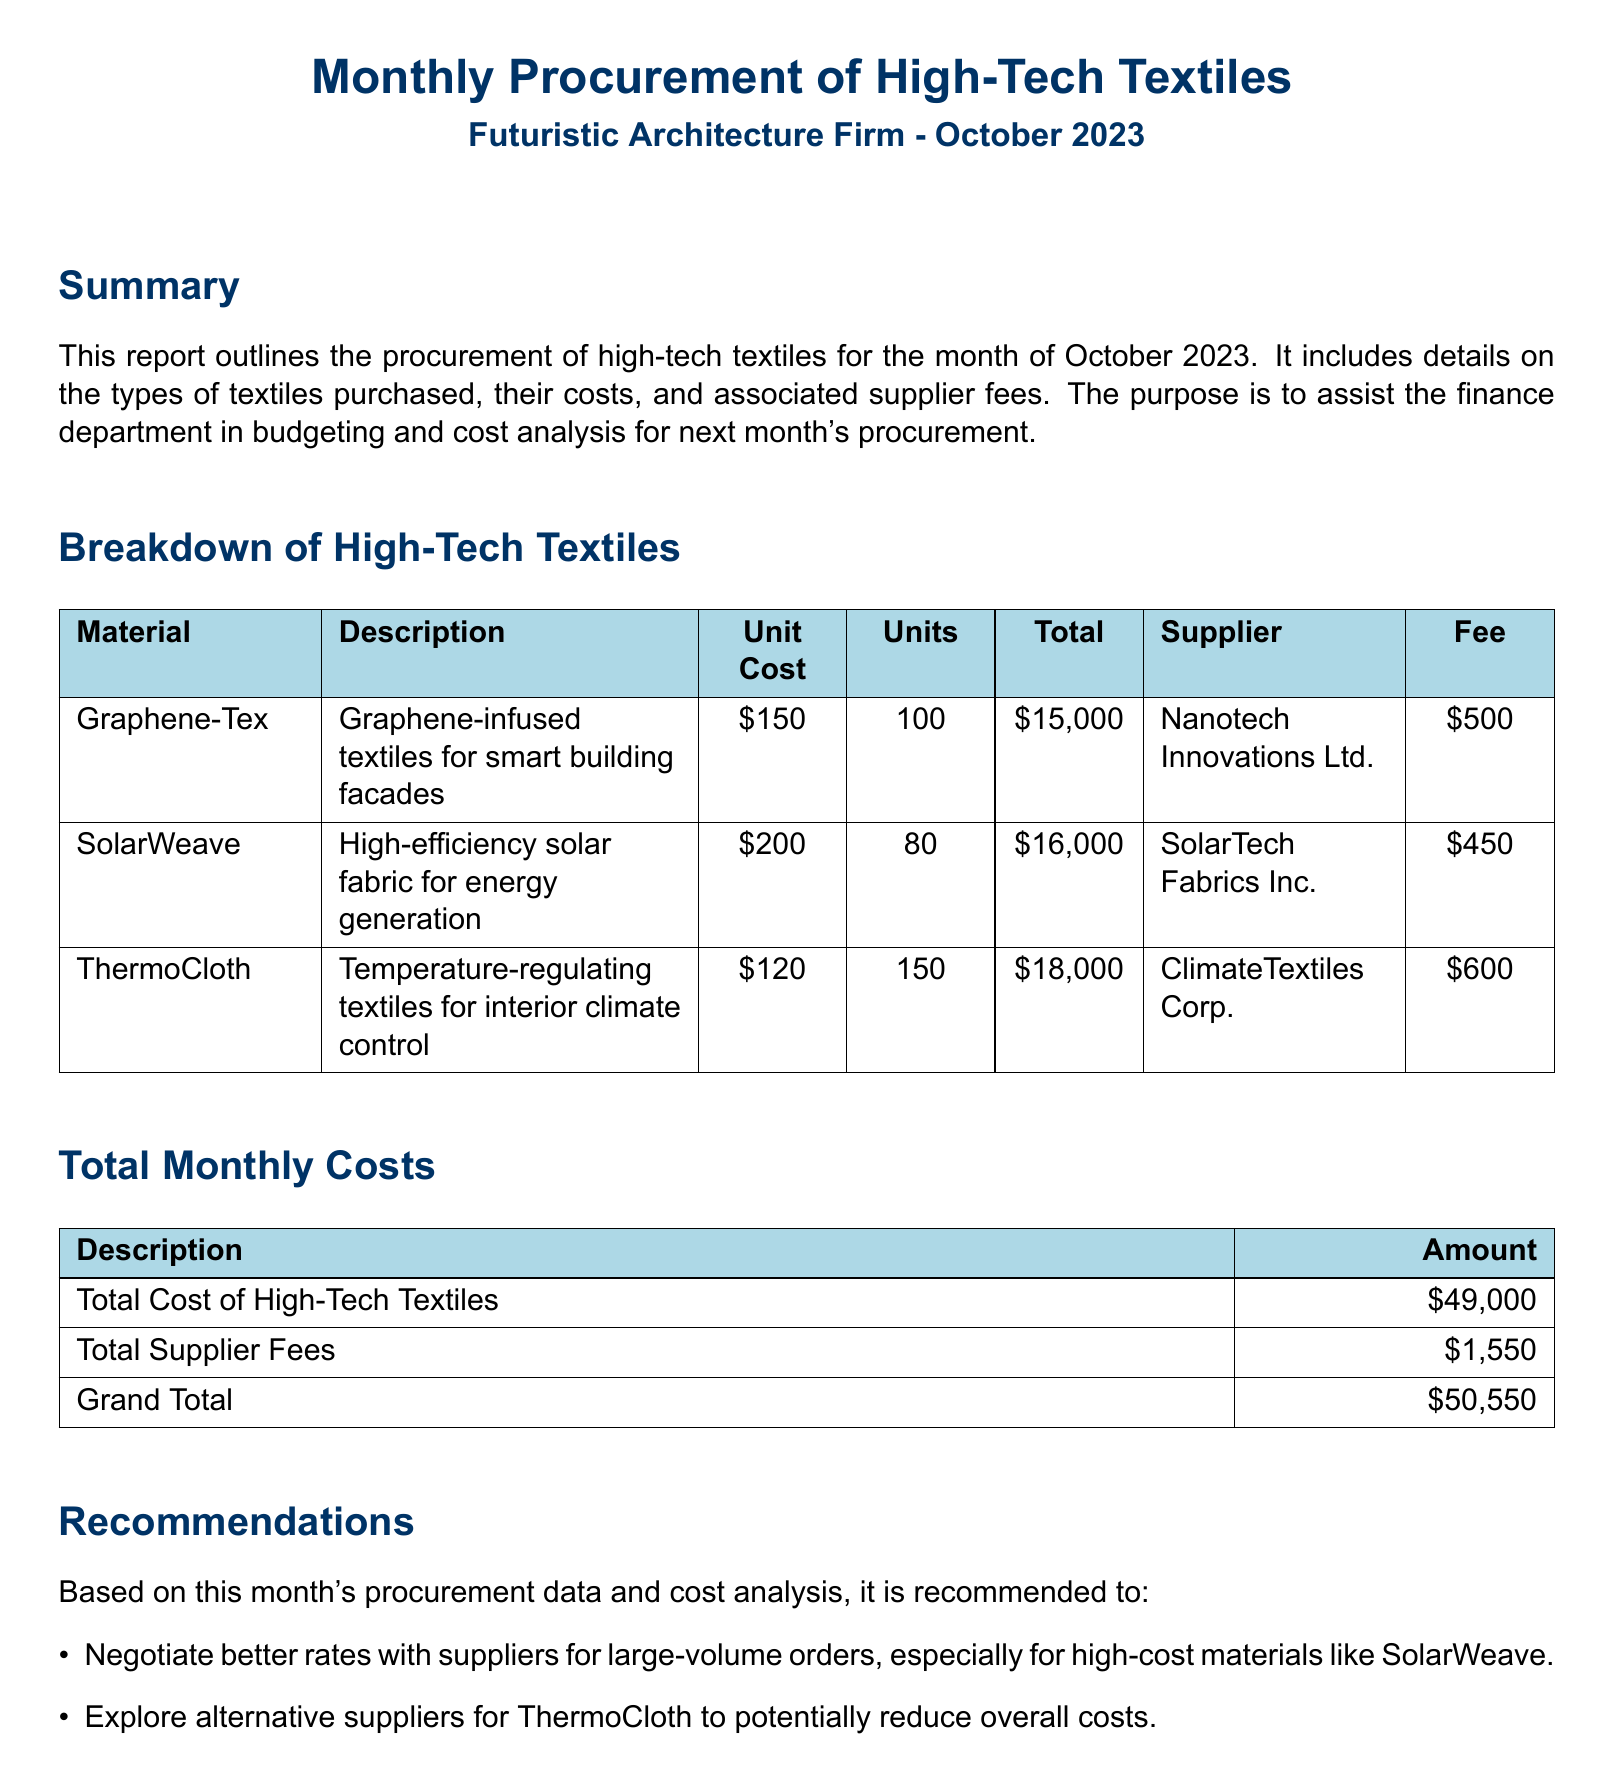What is the total cost of high-tech textiles? The total cost of high-tech textiles is stated in the document under total monthly costs.
Answer: $49,000 What is the name of the supplier for Graphene-Tex? The supplier's name for Graphene-Tex is listed in the breakdown section of the document.
Answer: Nanotech Innovations Ltd How many units of SolarWeave were purchased? The number of units purchased for SolarWeave is included in the breakdown of high-tech textiles.
Answer: 80 What is the unit cost of ThermoCloth? The unit cost for ThermoCloth is listed in the breakdown of high-tech textiles.
Answer: $120 What is the total supplier fee? The total supplier fees are summarized in the total monthly costs section of the document.
Answer: $1,550 What is the grand total of procurement costs? The grand total is presented in the total monthly costs section, combining all costs.
Answer: $50,550 What is recommended for SolarWeave? The recommendation related to SolarWeave is found in the recommendations section, indicating a possible action.
Answer: Negotiate better rates What is the description of Graphene-Tex? The description of Graphene-Tex is provided in the breakdown of high-tech textiles section.
Answer: Graphene-infused textiles for smart building facades 